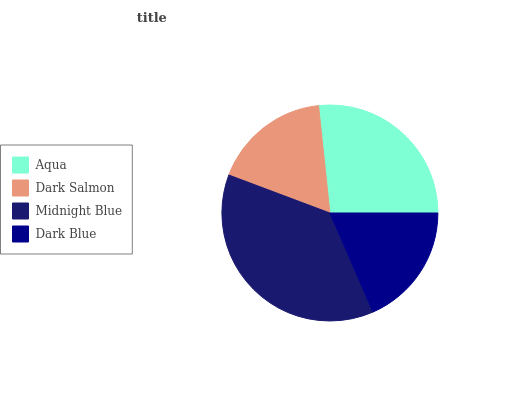Is Dark Salmon the minimum?
Answer yes or no. Yes. Is Midnight Blue the maximum?
Answer yes or no. Yes. Is Midnight Blue the minimum?
Answer yes or no. No. Is Dark Salmon the maximum?
Answer yes or no. No. Is Midnight Blue greater than Dark Salmon?
Answer yes or no. Yes. Is Dark Salmon less than Midnight Blue?
Answer yes or no. Yes. Is Dark Salmon greater than Midnight Blue?
Answer yes or no. No. Is Midnight Blue less than Dark Salmon?
Answer yes or no. No. Is Aqua the high median?
Answer yes or no. Yes. Is Dark Blue the low median?
Answer yes or no. Yes. Is Dark Salmon the high median?
Answer yes or no. No. Is Dark Salmon the low median?
Answer yes or no. No. 